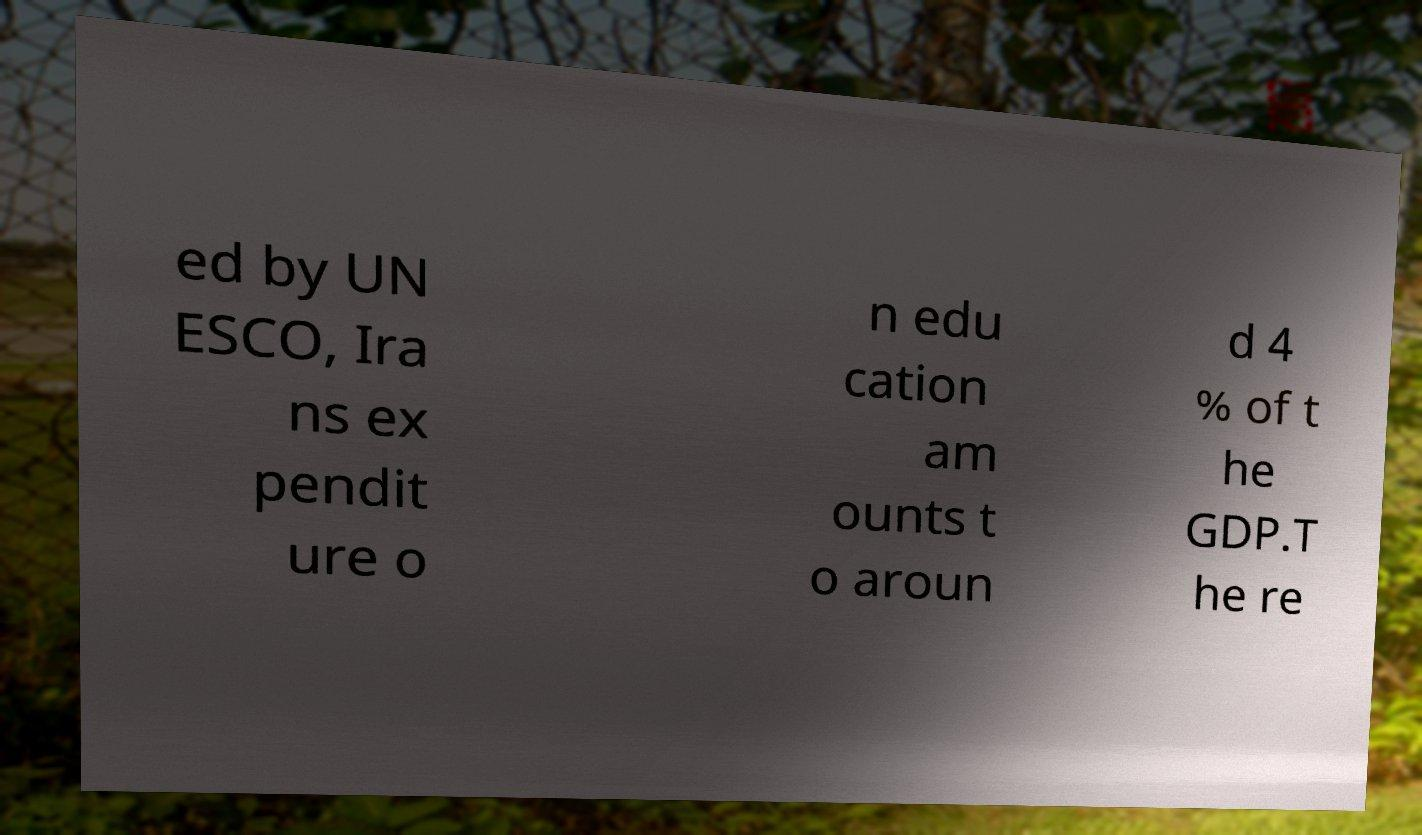I need the written content from this picture converted into text. Can you do that? ed by UN ESCO, Ira ns ex pendit ure o n edu cation am ounts t o aroun d 4 % of t he GDP.T he re 